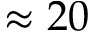<formula> <loc_0><loc_0><loc_500><loc_500>\approx 2 0</formula> 